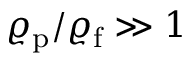Convert formula to latex. <formula><loc_0><loc_0><loc_500><loc_500>\varrho _ { p } / \varrho _ { f } \gg 1</formula> 